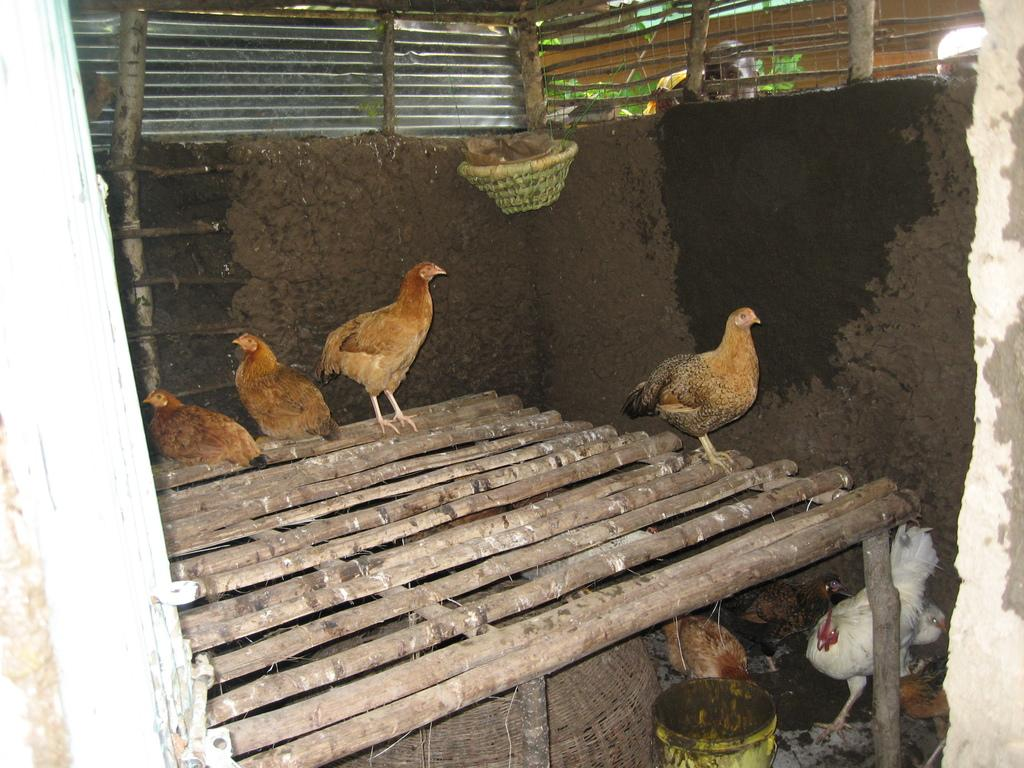What type of animal is the main subject of the image? There is a rooster in the image. Can you describe the color of the rooster? The rooster is white in color. Are there any other animals present in the image? Yes, there are hens in the image. What is the surface the animals are standing on? The animals are on a wooden surface. What can be seen in the background of the image? There is a wall in the background of the image, and there are other objects on the ground. Is the rooster using a bulb to light up the area in the image? There is no bulb present in the image, and the rooster is not using any light source. What type of food is being prepared in the oven in the image? There is no oven present in the image, as it features a rooster, hens, and a wooden surface. 